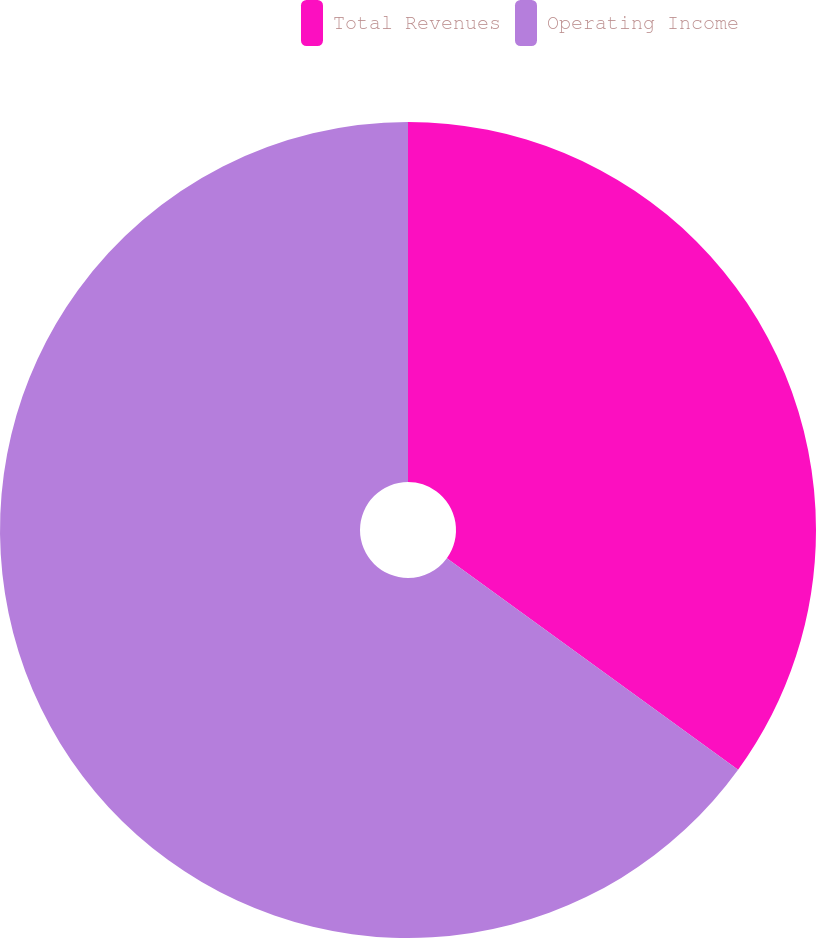<chart> <loc_0><loc_0><loc_500><loc_500><pie_chart><fcel>Total Revenues<fcel>Operating Income<nl><fcel>35.0%<fcel>65.0%<nl></chart> 